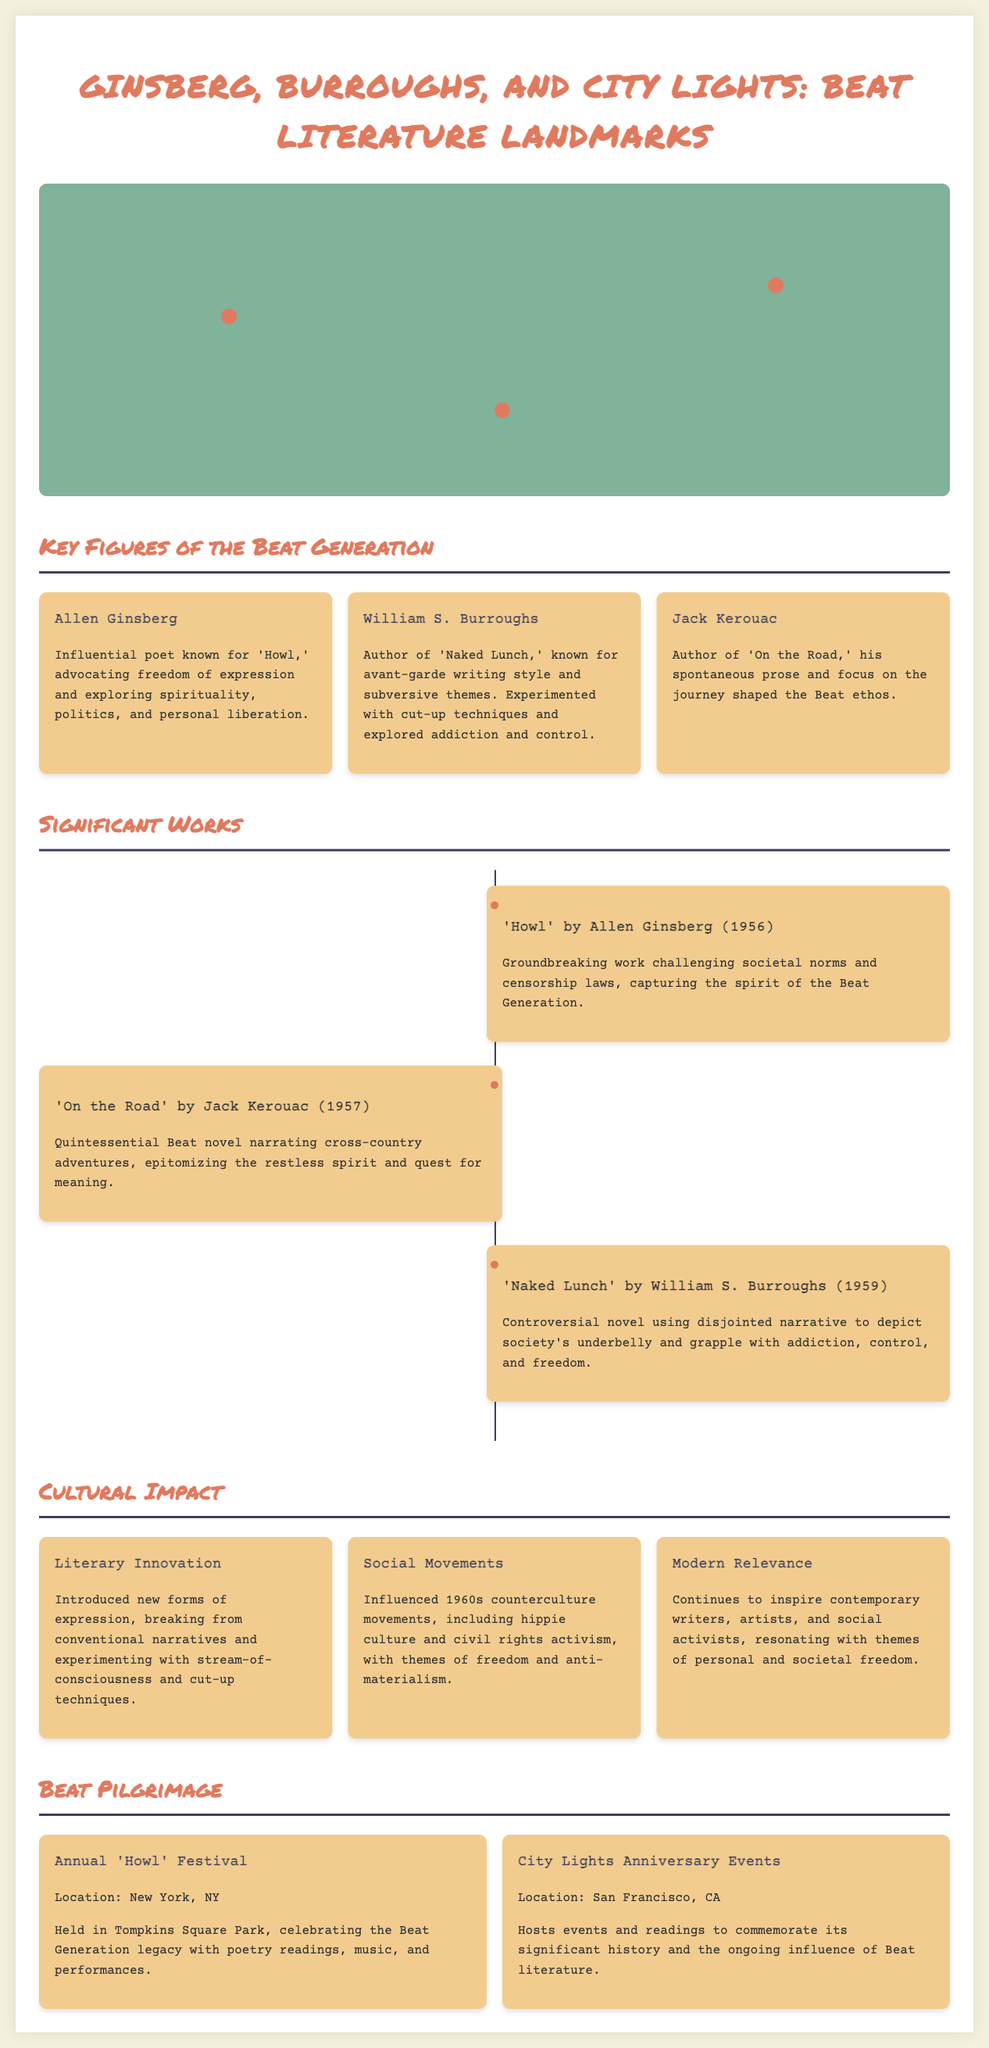What is the title of Allen Ginsberg's work mentioned? The document lists 'Howl' as the groundbreaking work by Allen Ginsberg.
Answer: Howl Which city is home to City Lights Bookstore? The map indicates that City Lights Bookstore is located in San Francisco, CA.
Answer: San Francisco In what year was 'On the Road' by Jack Kerouac published? The document states that 'On the Road' was published in 1957.
Answer: 1957 What significant location is associated with William S. Burroughs? The infographic identifies Tangier, Morocco, as a significant location for Burroughs' writing.
Answer: Tangier What type of events are held at City Lights to commemorate its history? The text describes events as part of City Lights Anniversary Events in San Francisco, CA.
Answer: Anniversary Events How does Beat literature continue to influence modern times? The document mentions ongoing inspiration for contemporary writers and artists.
Answer: Inspiration What is the setting for the Annual 'Howl' Festival? The Annual 'Howl' Festival takes place in Tompkins Square Park, as indicated in the document.
Answer: Tompkins Square Park Which literary technique is associated with William S. Burroughs? The document mentions that Burroughs experimented with cut-up techniques in his writing.
Answer: Cut-up techniques 